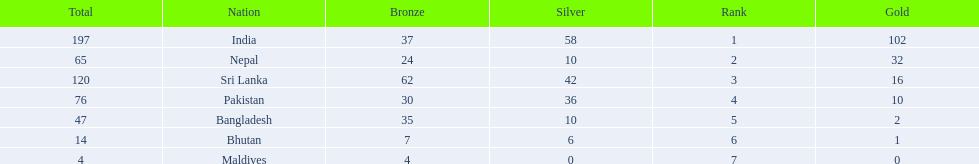Name a country listed in the table, other than india? Nepal. 